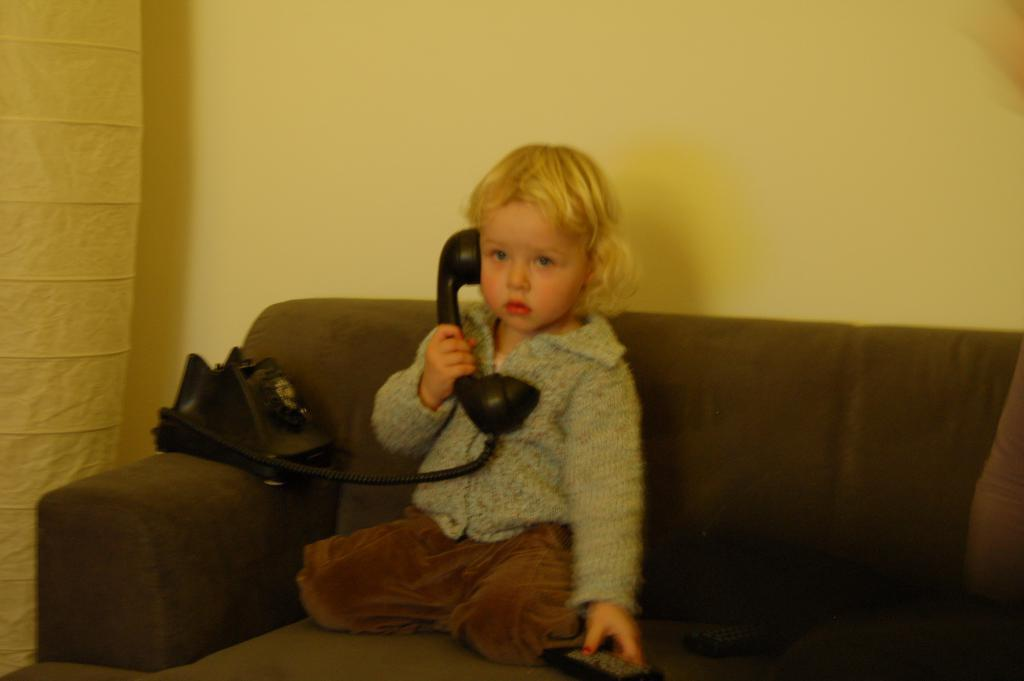Where was the image taken? The image is taken indoors. What can be seen in the background of the image? There is a wall with a curtain in the background. What piece of furniture is in the middle of the image? There is a couch in the middle of the image. What is the kid in the image doing? The kid is talking on the phone in the image. What type of silver material is being used for the journey in the image? There is no silver material or journey present in the image. How does the kid pull the curtain in the image? The kid is not shown pulling the curtain in the image; they are talking on the phone. 